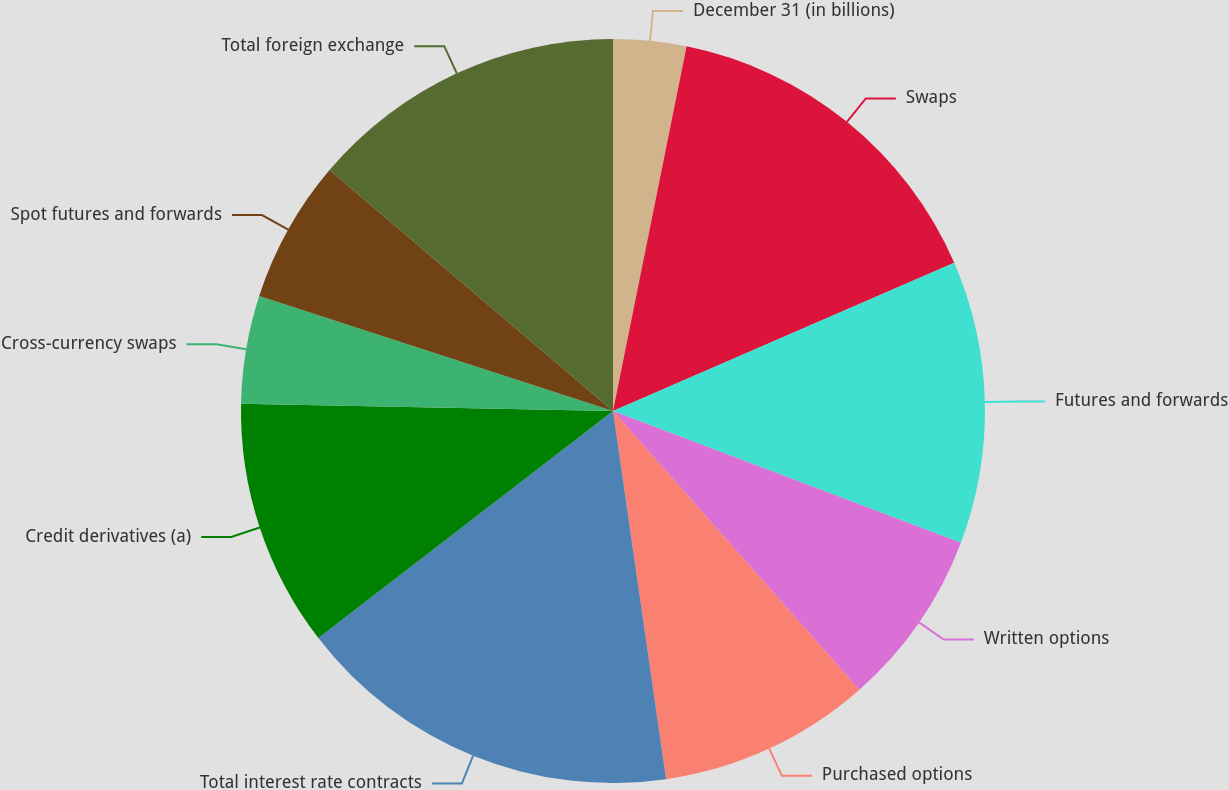Convert chart to OTSL. <chart><loc_0><loc_0><loc_500><loc_500><pie_chart><fcel>December 31 (in billions)<fcel>Swaps<fcel>Futures and forwards<fcel>Written options<fcel>Purchased options<fcel>Total interest rate contracts<fcel>Credit derivatives (a)<fcel>Cross-currency swaps<fcel>Spot futures and forwards<fcel>Total foreign exchange<nl><fcel>3.17%<fcel>15.31%<fcel>12.28%<fcel>7.72%<fcel>9.24%<fcel>16.83%<fcel>10.76%<fcel>4.69%<fcel>6.21%<fcel>13.79%<nl></chart> 